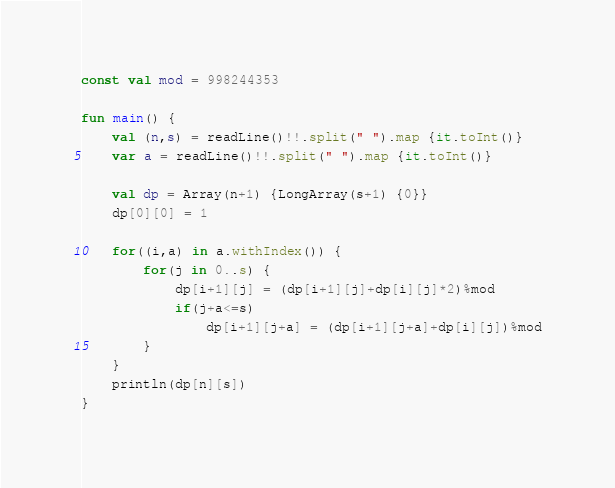Convert code to text. <code><loc_0><loc_0><loc_500><loc_500><_Kotlin_>const val mod = 998244353

fun main() {
	val (n,s) = readLine()!!.split(" ").map {it.toInt()}
	var a = readLine()!!.split(" ").map {it.toInt()}

	val dp = Array(n+1) {LongArray(s+1) {0}}
	dp[0][0] = 1

	for((i,a) in a.withIndex()) {
		for(j in 0..s) {
			dp[i+1][j] = (dp[i+1][j]+dp[i][j]*2)%mod
			if(j+a<=s)
				dp[i+1][j+a] = (dp[i+1][j+a]+dp[i][j])%mod
		}
	}
	println(dp[n][s])
}
</code> 